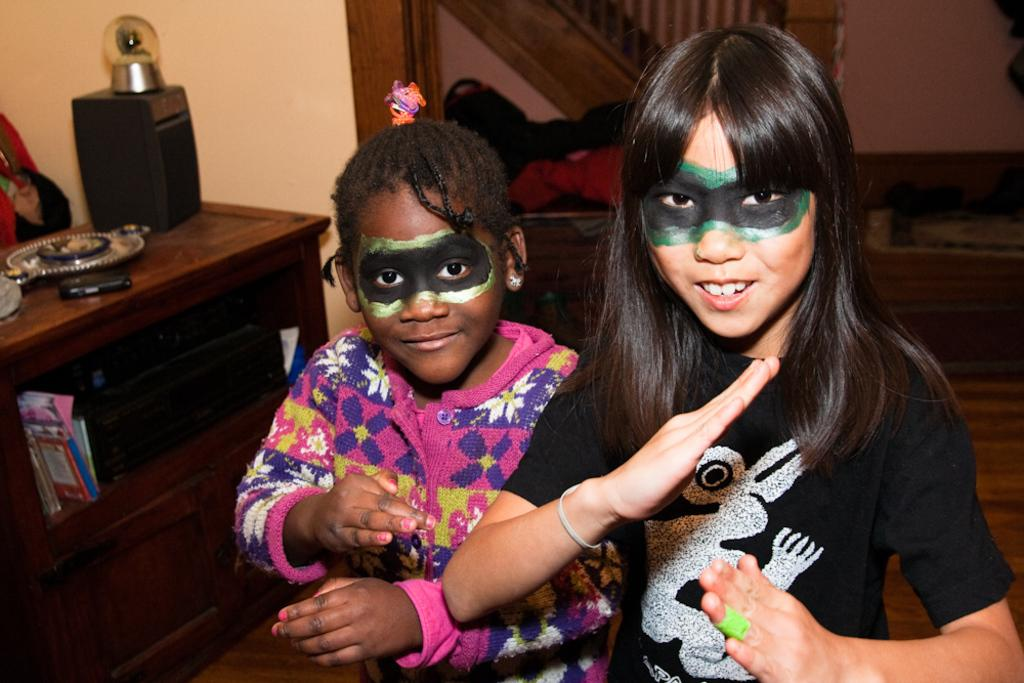How many people are present in the image? There are two people in the image. What can be seen on the table in the image? There is a table with objects in the image. What architectural feature is visible in the background of the image? There is a handrail in the background of the image. What type of structure is present in the background of the image? There is a wall in the background of the image. Where is the shelf located in the image? There is no shelf present in the image. What type of hydrant can be seen in the image? There is no hydrant present in the image. 